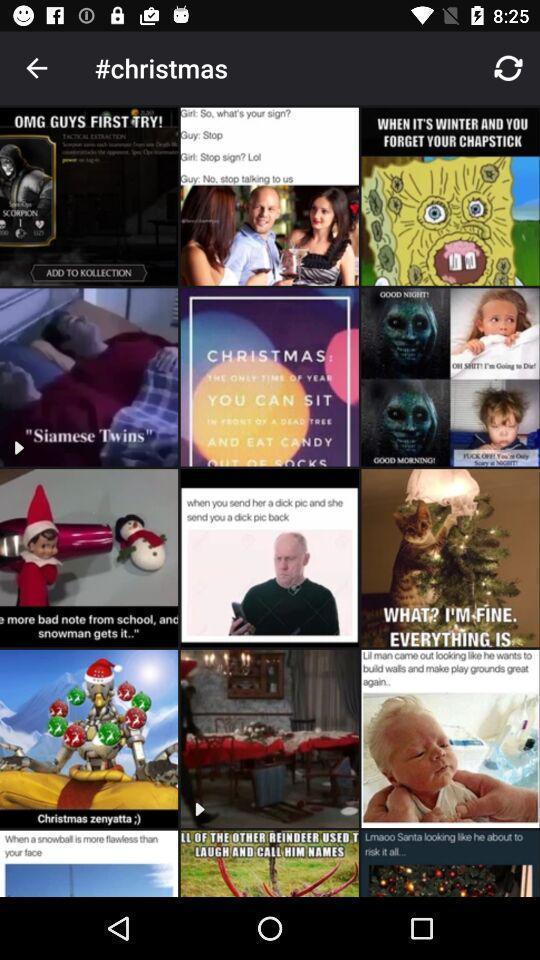Tell me about the visual elements in this screen capture. Screen shows different christmas images. 